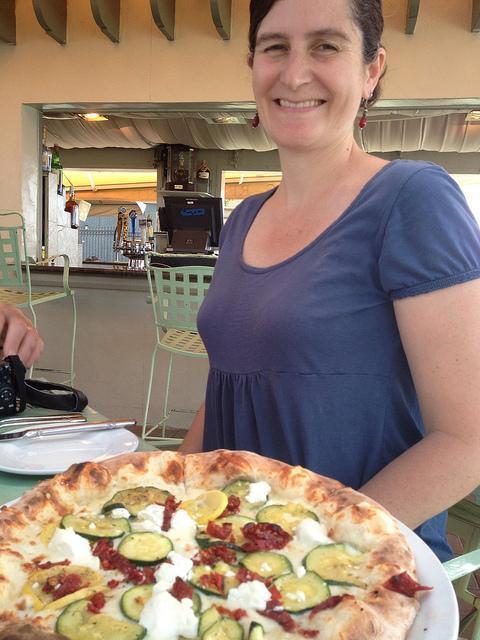How many chairs are in the picture?
Give a very brief answer. 2. 